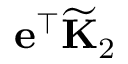Convert formula to latex. <formula><loc_0><loc_0><loc_500><loc_500>e ^ { \top } \widetilde { K } _ { 2 }</formula> 